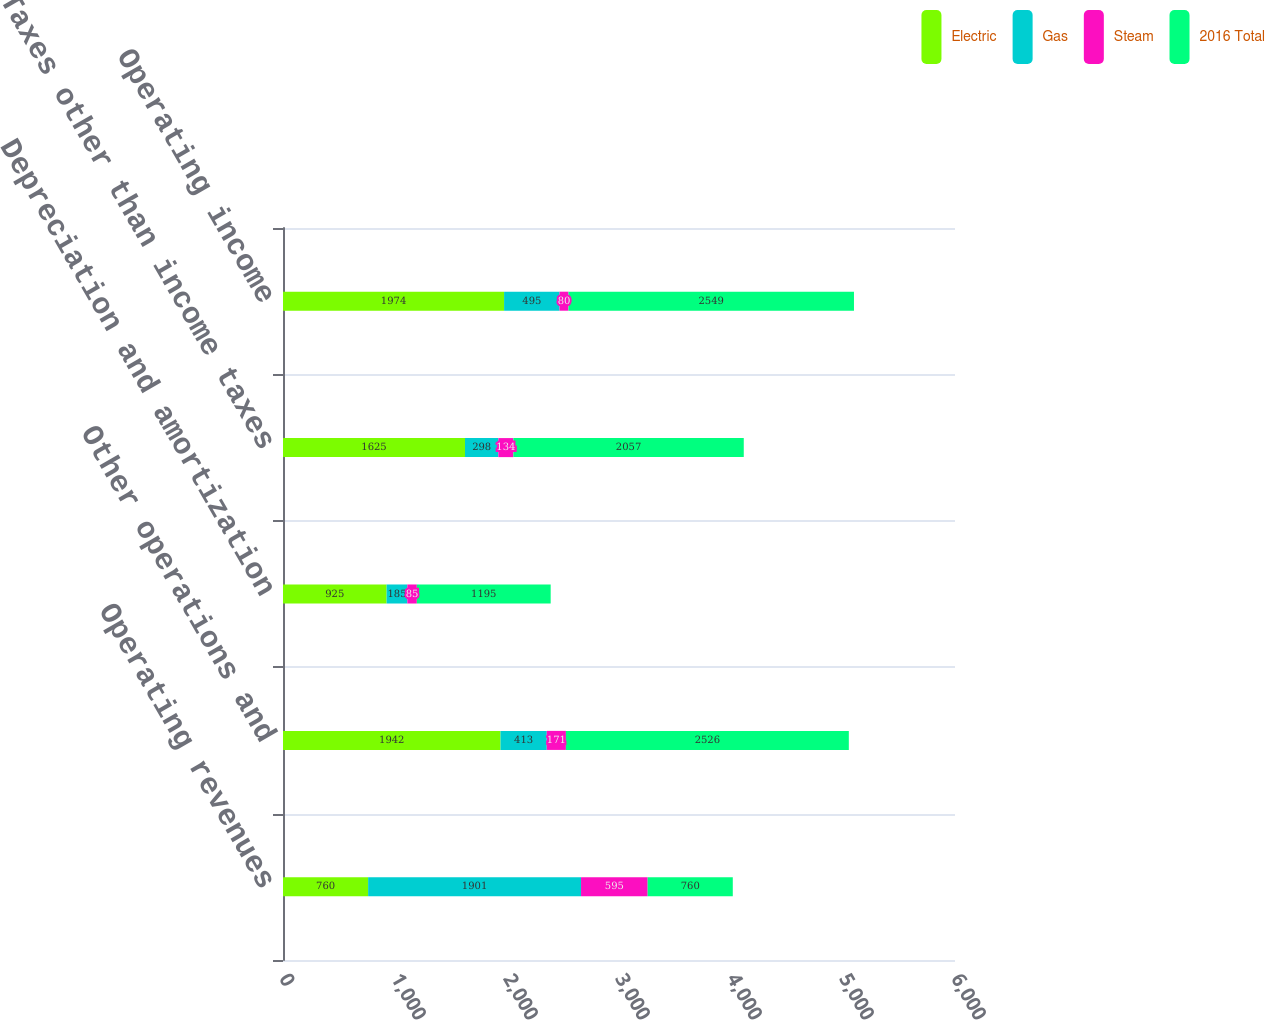Convert chart to OTSL. <chart><loc_0><loc_0><loc_500><loc_500><stacked_bar_chart><ecel><fcel>Operating revenues<fcel>Other operations and<fcel>Depreciation and amortization<fcel>Taxes other than income taxes<fcel>Operating income<nl><fcel>Electric<fcel>760<fcel>1942<fcel>925<fcel>1625<fcel>1974<nl><fcel>Gas<fcel>1901<fcel>413<fcel>185<fcel>298<fcel>495<nl><fcel>Steam<fcel>595<fcel>171<fcel>85<fcel>134<fcel>80<nl><fcel>2016 Total<fcel>760<fcel>2526<fcel>1195<fcel>2057<fcel>2549<nl></chart> 